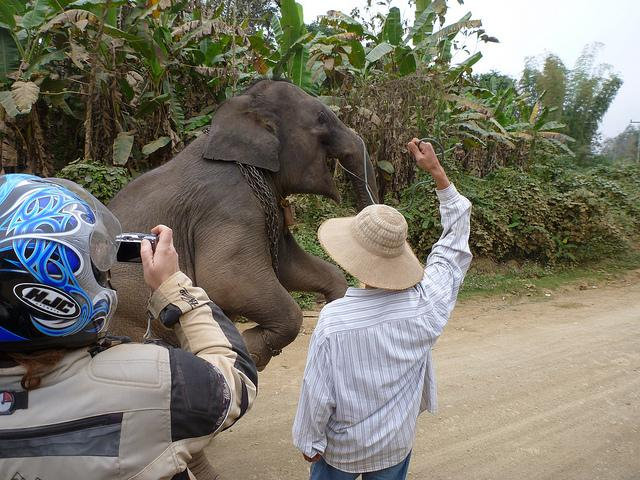Why does the man use a rope?

Choices:
A) control
B) tie
C) climb
D) attach control 